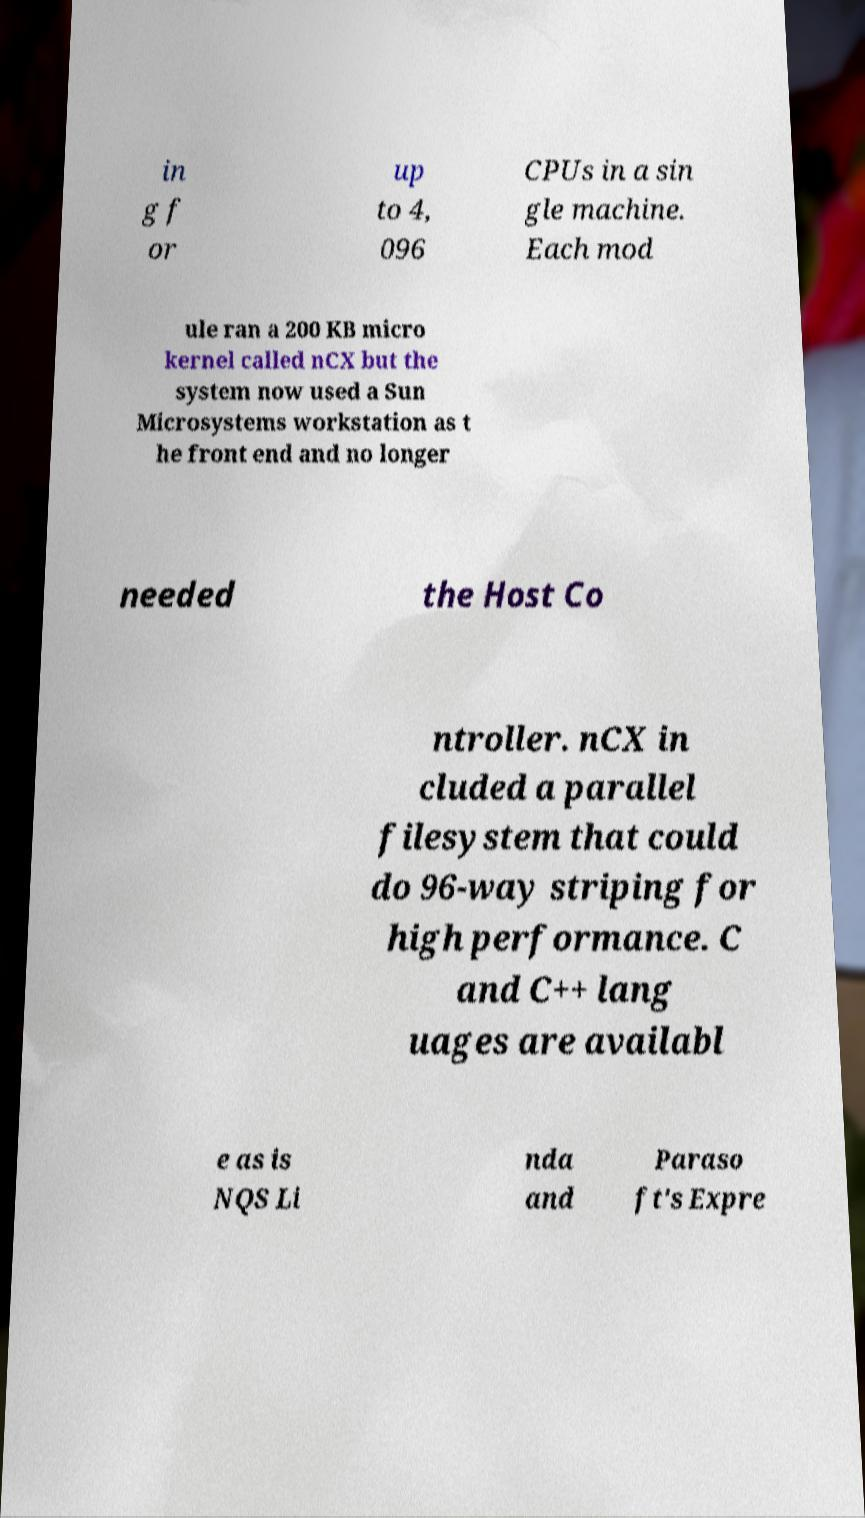There's text embedded in this image that I need extracted. Can you transcribe it verbatim? in g f or up to 4, 096 CPUs in a sin gle machine. Each mod ule ran a 200 KB micro kernel called nCX but the system now used a Sun Microsystems workstation as t he front end and no longer needed the Host Co ntroller. nCX in cluded a parallel filesystem that could do 96-way striping for high performance. C and C++ lang uages are availabl e as is NQS Li nda and Paraso ft's Expre 